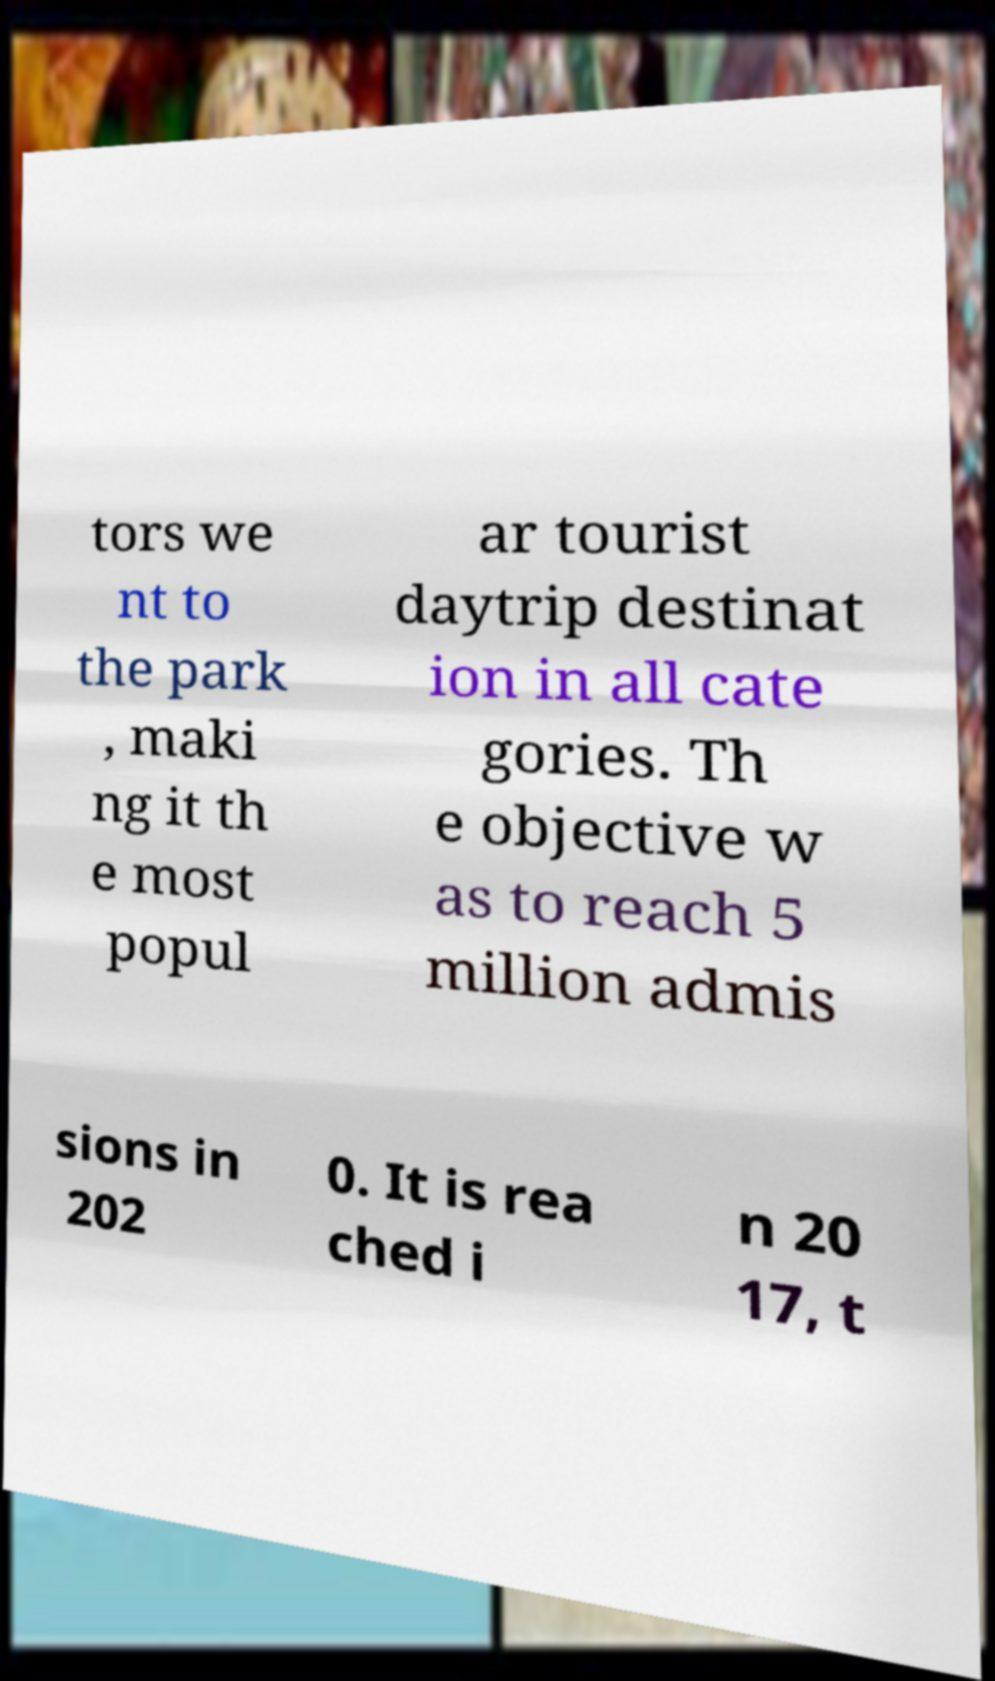Can you read and provide the text displayed in the image?This photo seems to have some interesting text. Can you extract and type it out for me? tors we nt to the park , maki ng it th e most popul ar tourist daytrip destinat ion in all cate gories. Th e objective w as to reach 5 million admis sions in 202 0. It is rea ched i n 20 17, t 